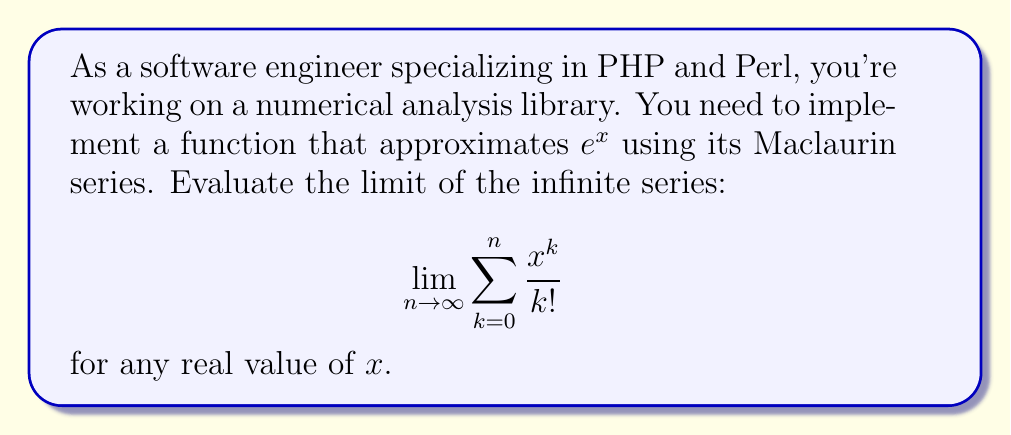What is the answer to this math problem? Let's approach this step-by-step:

1) First, recall the Maclaurin series for $e^x$:

   $$e^x = 1 + x + \frac{x^2}{2!} + \frac{x^3}{3!} + \frac{x^4}{4!} + \cdots$$

2) We can write this as an infinite sum:

   $$e^x = \sum_{k=0}^{\infty} \frac{x^k}{k!}$$

3) The series in our question is the partial sum of this series:

   $$S_n = \sum_{k=0}^n \frac{x^k}{k!}$$

4) As $n$ approaches infinity, this partial sum approaches the full infinite series:

   $$\lim_{n \to \infty} S_n = \lim_{n \to \infty} \sum_{k=0}^n \frac{x^k}{k!} = \sum_{k=0}^{\infty} \frac{x^k}{k!}$$

5) From step 2, we know that this infinite sum is equal to $e^x$.

6) Therefore, we can conclude:

   $$\lim_{n \to \infty} \sum_{k=0}^n \frac{x^k}{k!} = e^x$$

This result holds for any real value of $x$, which makes it particularly useful for numerical approximations in software implementations.
Answer: $e^x$ 